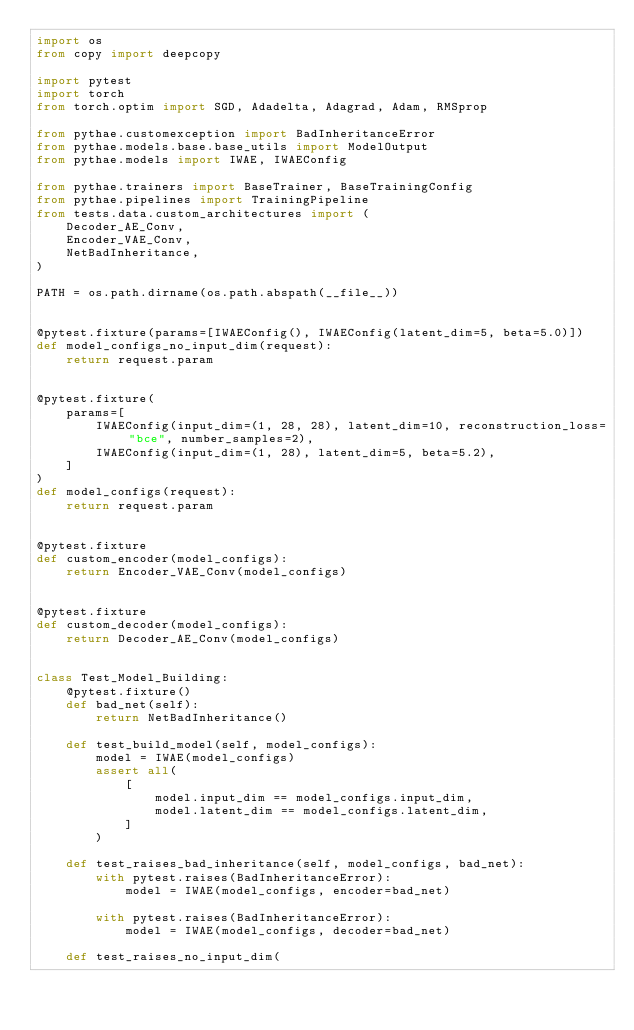Convert code to text. <code><loc_0><loc_0><loc_500><loc_500><_Python_>import os
from copy import deepcopy

import pytest
import torch
from torch.optim import SGD, Adadelta, Adagrad, Adam, RMSprop

from pythae.customexception import BadInheritanceError
from pythae.models.base.base_utils import ModelOutput
from pythae.models import IWAE, IWAEConfig

from pythae.trainers import BaseTrainer, BaseTrainingConfig
from pythae.pipelines import TrainingPipeline
from tests.data.custom_architectures import (
    Decoder_AE_Conv,
    Encoder_VAE_Conv,
    NetBadInheritance,
)

PATH = os.path.dirname(os.path.abspath(__file__))


@pytest.fixture(params=[IWAEConfig(), IWAEConfig(latent_dim=5, beta=5.0)])
def model_configs_no_input_dim(request):
    return request.param


@pytest.fixture(
    params=[
        IWAEConfig(input_dim=(1, 28, 28), latent_dim=10, reconstruction_loss="bce", number_samples=2),
        IWAEConfig(input_dim=(1, 28), latent_dim=5, beta=5.2),
    ]
)
def model_configs(request):
    return request.param


@pytest.fixture
def custom_encoder(model_configs):
    return Encoder_VAE_Conv(model_configs)


@pytest.fixture
def custom_decoder(model_configs):
    return Decoder_AE_Conv(model_configs)


class Test_Model_Building:
    @pytest.fixture()
    def bad_net(self):
        return NetBadInheritance()

    def test_build_model(self, model_configs):
        model = IWAE(model_configs)
        assert all(
            [
                model.input_dim == model_configs.input_dim,
                model.latent_dim == model_configs.latent_dim,
            ]
        )

    def test_raises_bad_inheritance(self, model_configs, bad_net):
        with pytest.raises(BadInheritanceError):
            model = IWAE(model_configs, encoder=bad_net)

        with pytest.raises(BadInheritanceError):
            model = IWAE(model_configs, decoder=bad_net)

    def test_raises_no_input_dim(</code> 